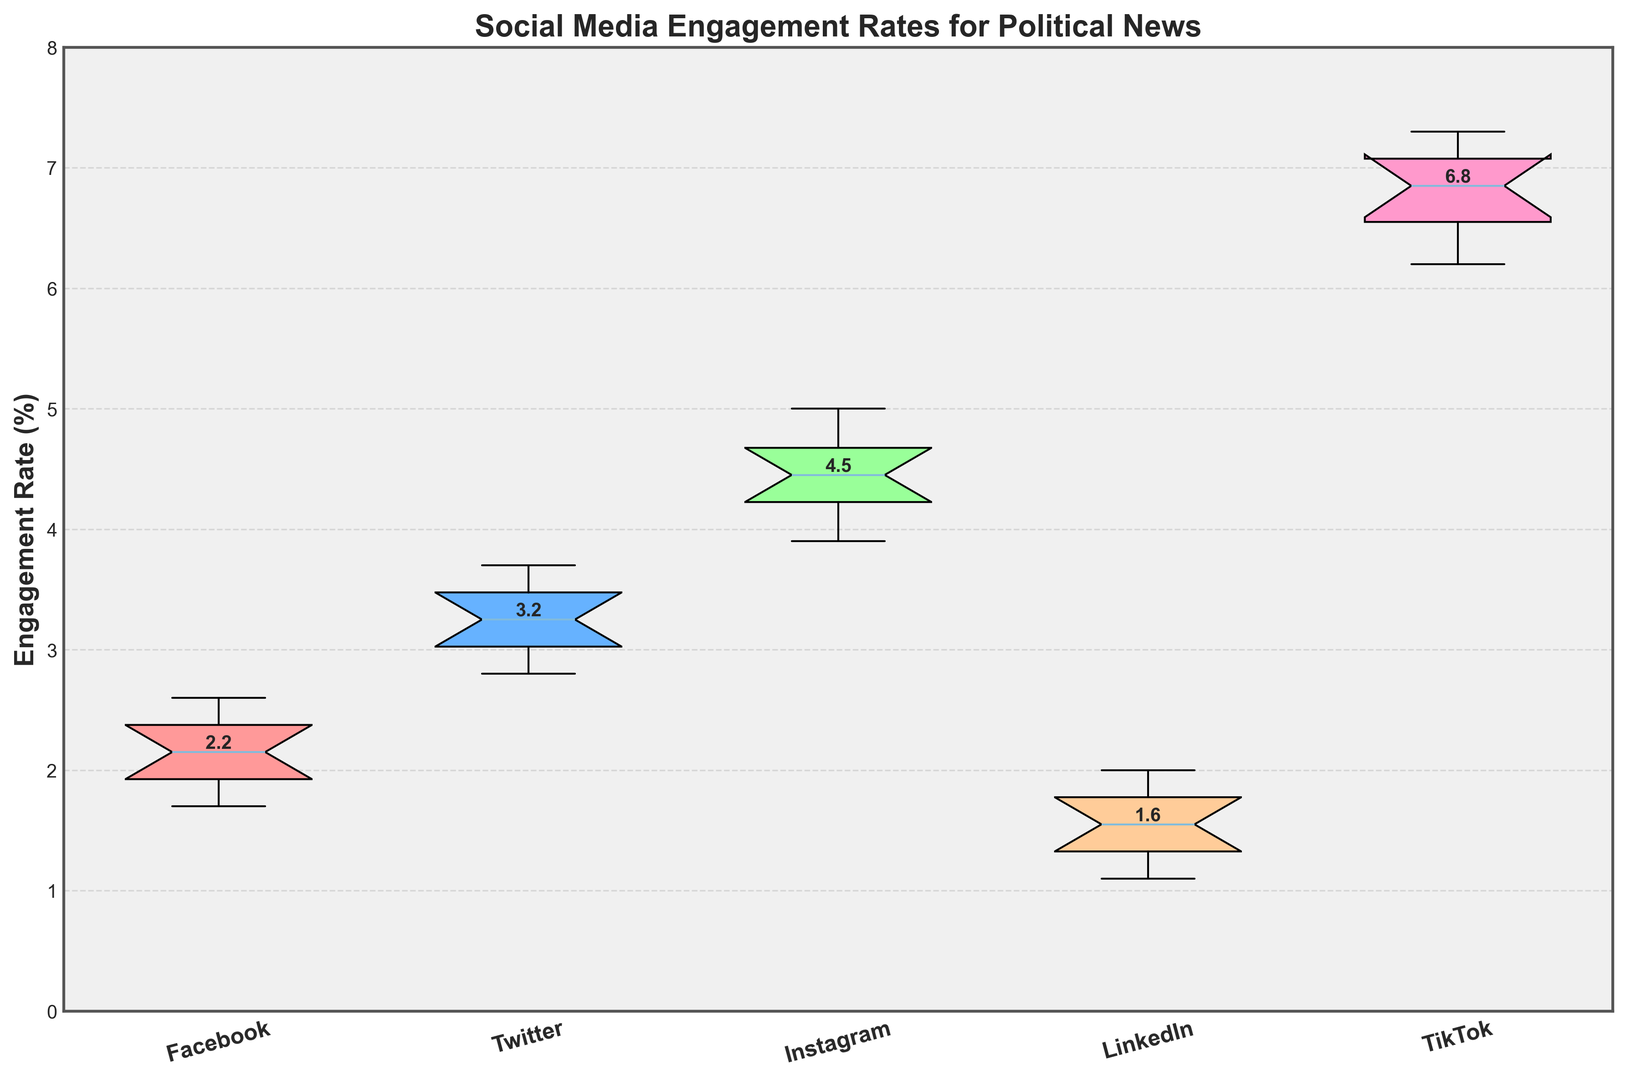Which platform has the highest median engagement rate? To determine the platform with the highest median engagement rate, look for the middle value of the engagement rates within each platform's boxplot. Instagram has a dot representing the median that is higher than the medians of Facebook, Twitter, LinkedIn, and TikTok. The exact position of the medians shows Instagram has the highest median.
Answer: Instagram Which platform exhibits the widest range of engagement rates? The range of a boxplot is indicated by the length of the whiskers and box combined. TikTok's boxplot extends the furthest from the minimum to the maximum, indicating it has the widest range of engagement rates among the platforms.
Answer: TikTok Which platform has the lowest median engagement rate? To find the platform with the lowest median engagement rate, examine the position of the median line within each boxplot. LinkedIn's median line is the lowest compared to the medians of Facebook, Twitter, Instagram, and TikTok.
Answer: LinkedIn What is the interquartile range (IQR) of engagement rates for Twitter? The interquartile range (IQR) is the length of the box in the boxplot, which represents the middle 50% of the data. To find the IQR, measure the distance between the bottom edge of the box (Q1) and the top edge of the box (Q3) for Twitter's boxplot. The approximate values are Q1 ≈ 2.9 and Q3 ≈ 3.6. Therefore, the IQR = Q3 - Q1 = 3.6 - 2.9.
Answer: 0.7 How does the median engagement rate on Instagram compare to that on TikTok? Compare the median lines (dots) within the boxes of Instagram and TikTok. Instagram's median is at 4.5, and TikTok's median is at 6.9, indicating TikTok's median engagement rate is higher.
Answer: TikTok's median is higher How many platforms have a higher median engagement rate than Facebook? First, identify the median engagement rate of Facebook, which is around 2.2. Then, compare it to the medians of other platforms. Both Instagram (4.5) and TikTok (6.9) have higher median engagement rates than Facebook.
Answer: 2 platforms What's the difference between the median engagement rate of Instagram and LinkedIn? To find the difference, subtract the median engagement rate of LinkedIn from that of Instagram. The medians are approximately 4.5 (Instagram) and 1.5 (LinkedIn). Therefore, the difference is 4.5 - 1.5.
Answer: 3.0 Which platform's engagement rate has the least variability? Variability in a boxplot is indicated by the range (the length of the whiskers and box). LinkedIn has the shortest whiskers and box length, indicating the least variability in engagement rates.
Answer: LinkedIn What percentage of TikTok's engagement rates are above 7.0? Evaluate the position of the upper quartile (top of the box) and the whiskers. The top of TikTok's box ends around 7.1, and only one whisker extends slightly above it. This means approximately 25% of TikTok's engagement rates are above 7.0.
Answer: ~25% Which platform shows the most consistent engagement rate close to its median? Consistency around the median is indicated by the spread of data near the median (box and whiskers). Twitter's data points are most closely clustered around its median with the smallest overall spread, suggesting consistency near its median.
Answer: Twitter 